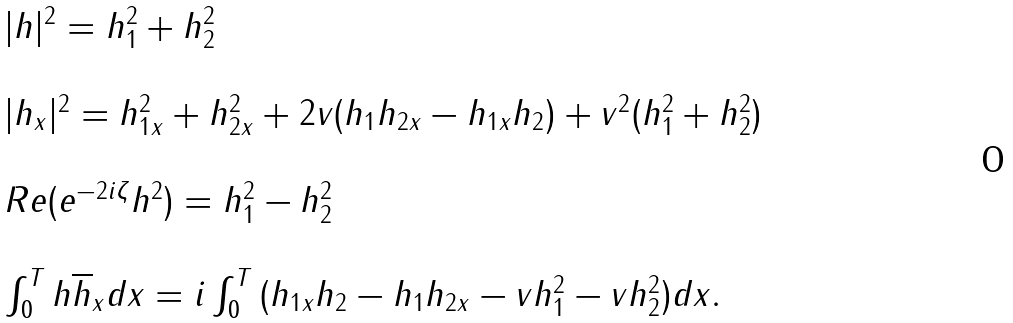Convert formula to latex. <formula><loc_0><loc_0><loc_500><loc_500>\begin{array} { l l } | h | ^ { 2 } = h _ { 1 } ^ { 2 } + h _ { 2 } ^ { 2 } \\ \\ | h _ { x } | ^ { 2 } = h _ { 1 x } ^ { 2 } + h _ { 2 x } ^ { 2 } + 2 v ( h _ { 1 } h _ { 2 x } - h _ { 1 x } h _ { 2 } ) + v ^ { 2 } ( h _ { 1 } ^ { 2 } + h _ { 2 } ^ { 2 } ) \\ \\ R e ( e ^ { - 2 i \zeta } h ^ { 2 } ) = h _ { 1 } ^ { 2 } - h _ { 2 } ^ { 2 } \\ \\ \int _ { 0 } ^ { T } { h \overline { h } _ { x } } d x = i \int _ { 0 } ^ { T } { ( h _ { 1 x } h _ { 2 } - h _ { 1 } h _ { 2 x } - v h _ { 1 } ^ { 2 } - v h _ { 2 } ^ { 2 } ) } d x . \end{array}</formula> 